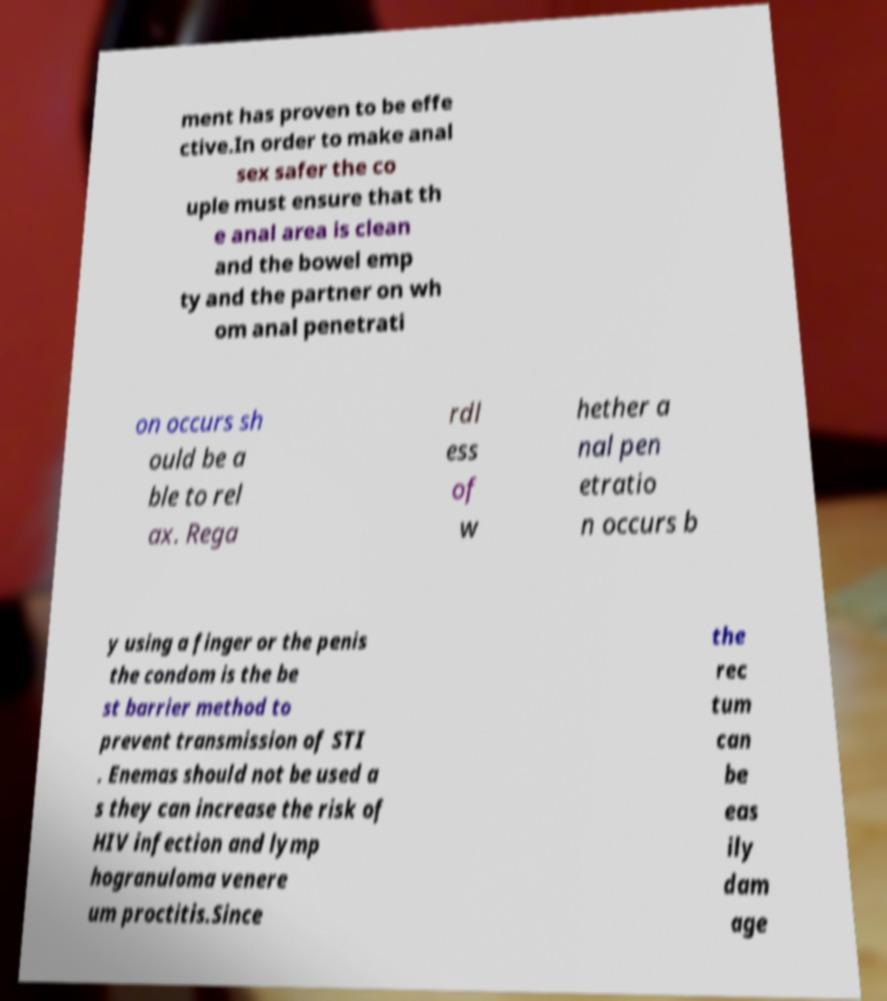Please identify and transcribe the text found in this image. ment has proven to be effe ctive.In order to make anal sex safer the co uple must ensure that th e anal area is clean and the bowel emp ty and the partner on wh om anal penetrati on occurs sh ould be a ble to rel ax. Rega rdl ess of w hether a nal pen etratio n occurs b y using a finger or the penis the condom is the be st barrier method to prevent transmission of STI . Enemas should not be used a s they can increase the risk of HIV infection and lymp hogranuloma venere um proctitis.Since the rec tum can be eas ily dam age 